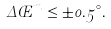Convert formula to latex. <formula><loc_0><loc_0><loc_500><loc_500>\Delta \phi ^ { m } \leq \pm 0 . 5 ^ { \circ } .</formula> 